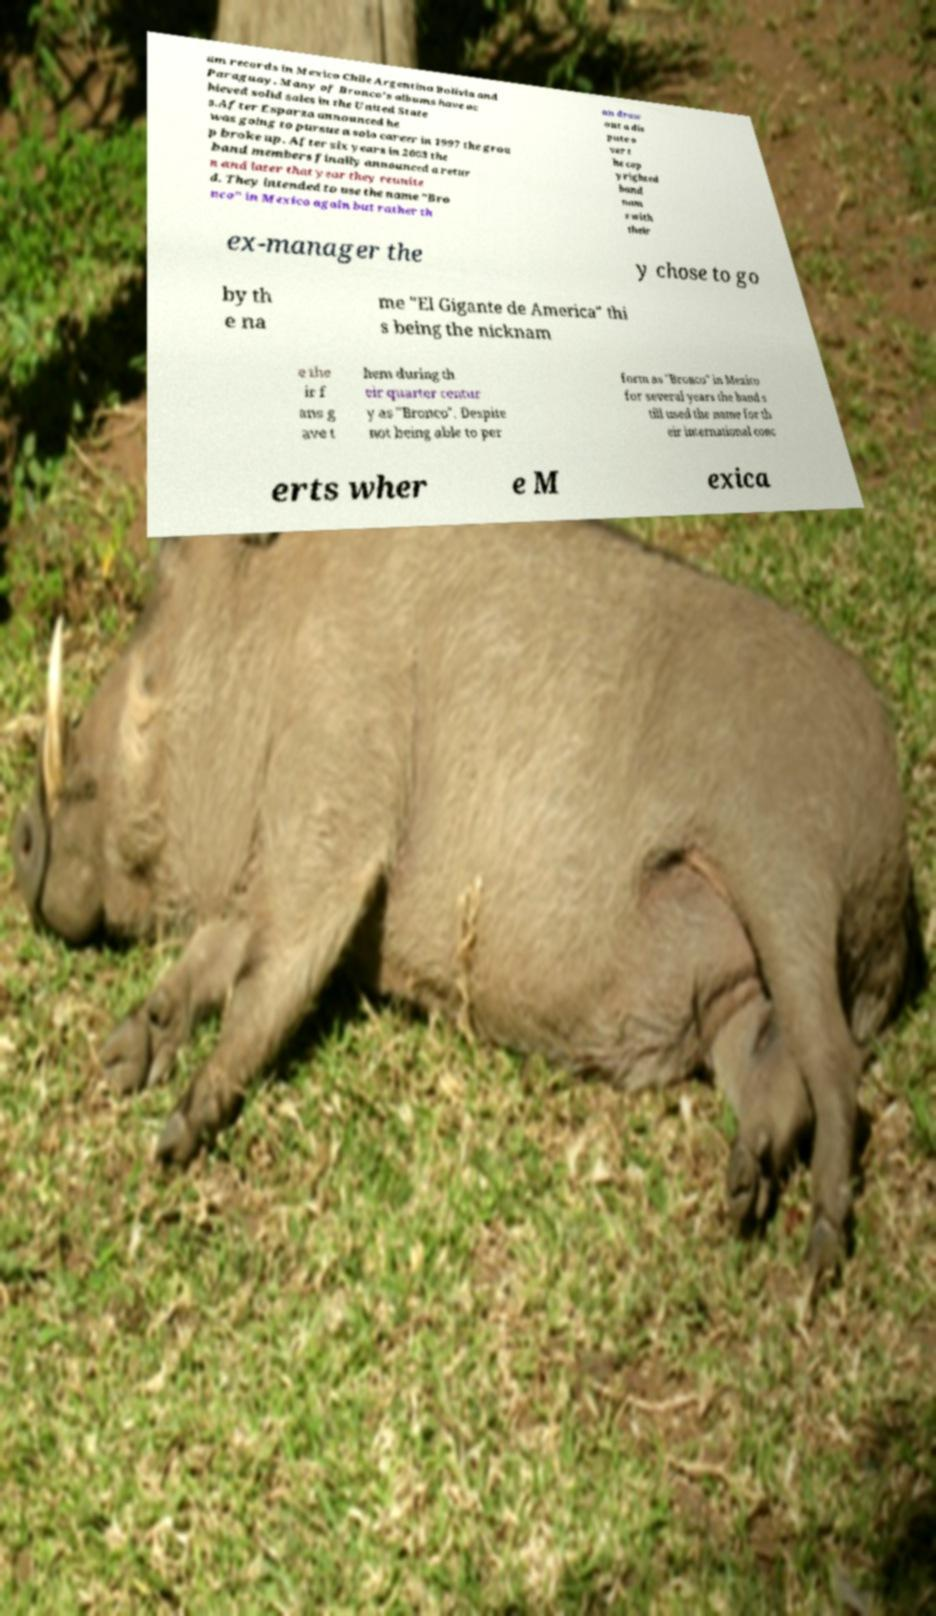There's text embedded in this image that I need extracted. Can you transcribe it verbatim? um records in Mexico Chile Argentina Bolivia and Paraguay. Many of Bronco's albums have ac hieved solid sales in the United State s.After Esparza announced he was going to pursue a solo career in 1997 the grou p broke up. After six years in 2003 the band members finally announced a retur n and later that year they reunite d. They intended to use the name "Bro nco" in Mexico again but rather th an draw out a dis pute o ver t he cop yrighted band nam e with their ex-manager the y chose to go by th e na me "El Gigante de America" thi s being the nicknam e the ir f ans g ave t hem during th eir quarter centur y as "Bronco". Despite not being able to per form as "Bronco" in Mexico for several years the band s till used the name for th eir international conc erts wher e M exica 